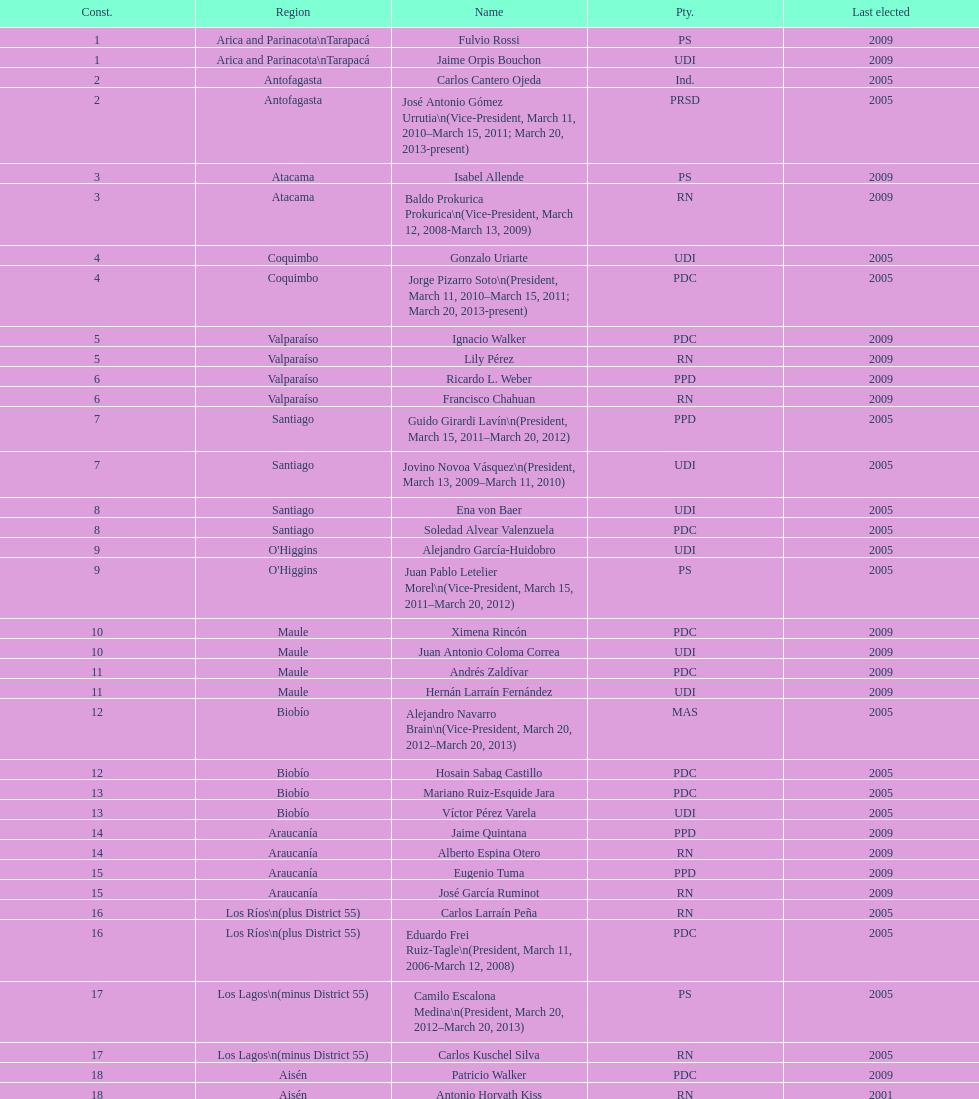Help me parse the entirety of this table. {'header': ['Const.', 'Region', 'Name', 'Pty.', 'Last elected'], 'rows': [['1', 'Arica and Parinacota\\nTarapacá', 'Fulvio Rossi', 'PS', '2009'], ['1', 'Arica and Parinacota\\nTarapacá', 'Jaime Orpis Bouchon', 'UDI', '2009'], ['2', 'Antofagasta', 'Carlos Cantero Ojeda', 'Ind.', '2005'], ['2', 'Antofagasta', 'José Antonio Gómez Urrutia\\n(Vice-President, March 11, 2010–March 15, 2011; March 20, 2013-present)', 'PRSD', '2005'], ['3', 'Atacama', 'Isabel Allende', 'PS', '2009'], ['3', 'Atacama', 'Baldo Prokurica Prokurica\\n(Vice-President, March 12, 2008-March 13, 2009)', 'RN', '2009'], ['4', 'Coquimbo', 'Gonzalo Uriarte', 'UDI', '2005'], ['4', 'Coquimbo', 'Jorge Pizarro Soto\\n(President, March 11, 2010–March 15, 2011; March 20, 2013-present)', 'PDC', '2005'], ['5', 'Valparaíso', 'Ignacio Walker', 'PDC', '2009'], ['5', 'Valparaíso', 'Lily Pérez', 'RN', '2009'], ['6', 'Valparaíso', 'Ricardo L. Weber', 'PPD', '2009'], ['6', 'Valparaíso', 'Francisco Chahuan', 'RN', '2009'], ['7', 'Santiago', 'Guido Girardi Lavín\\n(President, March 15, 2011–March 20, 2012)', 'PPD', '2005'], ['7', 'Santiago', 'Jovino Novoa Vásquez\\n(President, March 13, 2009–March 11, 2010)', 'UDI', '2005'], ['8', 'Santiago', 'Ena von Baer', 'UDI', '2005'], ['8', 'Santiago', 'Soledad Alvear Valenzuela', 'PDC', '2005'], ['9', "O'Higgins", 'Alejandro García-Huidobro', 'UDI', '2005'], ['9', "O'Higgins", 'Juan Pablo Letelier Morel\\n(Vice-President, March 15, 2011–March 20, 2012)', 'PS', '2005'], ['10', 'Maule', 'Ximena Rincón', 'PDC', '2009'], ['10', 'Maule', 'Juan Antonio Coloma Correa', 'UDI', '2009'], ['11', 'Maule', 'Andrés Zaldívar', 'PDC', '2009'], ['11', 'Maule', 'Hernán Larraín Fernández', 'UDI', '2009'], ['12', 'Biobío', 'Alejandro Navarro Brain\\n(Vice-President, March 20, 2012–March 20, 2013)', 'MAS', '2005'], ['12', 'Biobío', 'Hosain Sabag Castillo', 'PDC', '2005'], ['13', 'Biobío', 'Mariano Ruiz-Esquide Jara', 'PDC', '2005'], ['13', 'Biobío', 'Víctor Pérez Varela', 'UDI', '2005'], ['14', 'Araucanía', 'Jaime Quintana', 'PPD', '2009'], ['14', 'Araucanía', 'Alberto Espina Otero', 'RN', '2009'], ['15', 'Araucanía', 'Eugenio Tuma', 'PPD', '2009'], ['15', 'Araucanía', 'José García Ruminot', 'RN', '2009'], ['16', 'Los Ríos\\n(plus District 55)', 'Carlos Larraín Peña', 'RN', '2005'], ['16', 'Los Ríos\\n(plus District 55)', 'Eduardo Frei Ruiz-Tagle\\n(President, March 11, 2006-March 12, 2008)', 'PDC', '2005'], ['17', 'Los Lagos\\n(minus District 55)', 'Camilo Escalona Medina\\n(President, March 20, 2012–March 20, 2013)', 'PS', '2005'], ['17', 'Los Lagos\\n(minus District 55)', 'Carlos Kuschel Silva', 'RN', '2005'], ['18', 'Aisén', 'Patricio Walker', 'PDC', '2009'], ['18', 'Aisén', 'Antonio Horvath Kiss', 'RN', '2001'], ['19', 'Magallanes', 'Carlos Bianchi Chelech\\n(Vice-President, March 13, 2009–March 11, 2010)', 'Ind.', '2005'], ['19', 'Magallanes', 'Pedro Muñoz Aburto', 'PS', '2005']]} What is the total number of constituencies? 19. 